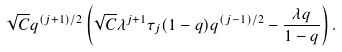Convert formula to latex. <formula><loc_0><loc_0><loc_500><loc_500>\sqrt { C } q ^ { ( j + 1 ) / 2 } \left ( \sqrt { C } \lambda ^ { j + 1 } \tau _ { j } ( 1 - q ) q ^ { ( j - 1 ) / 2 } - \frac { \lambda q } { 1 - q } \right ) .</formula> 